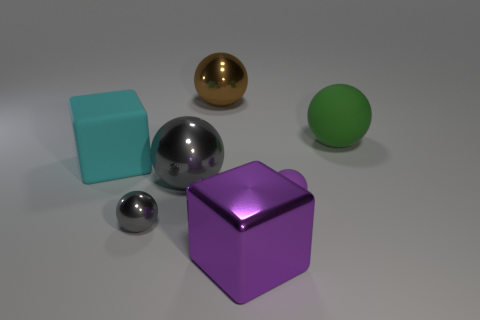Subtract all green spheres. How many spheres are left? 4 Subtract all purple spheres. How many spheres are left? 4 Add 3 purple shiny spheres. How many objects exist? 10 Subtract all blue spheres. Subtract all gray blocks. How many spheres are left? 5 Subtract all balls. How many objects are left? 2 Add 4 small yellow matte objects. How many small yellow matte objects exist? 4 Subtract 0 green blocks. How many objects are left? 7 Subtract all brown objects. Subtract all large yellow balls. How many objects are left? 6 Add 7 cyan matte things. How many cyan matte things are left? 8 